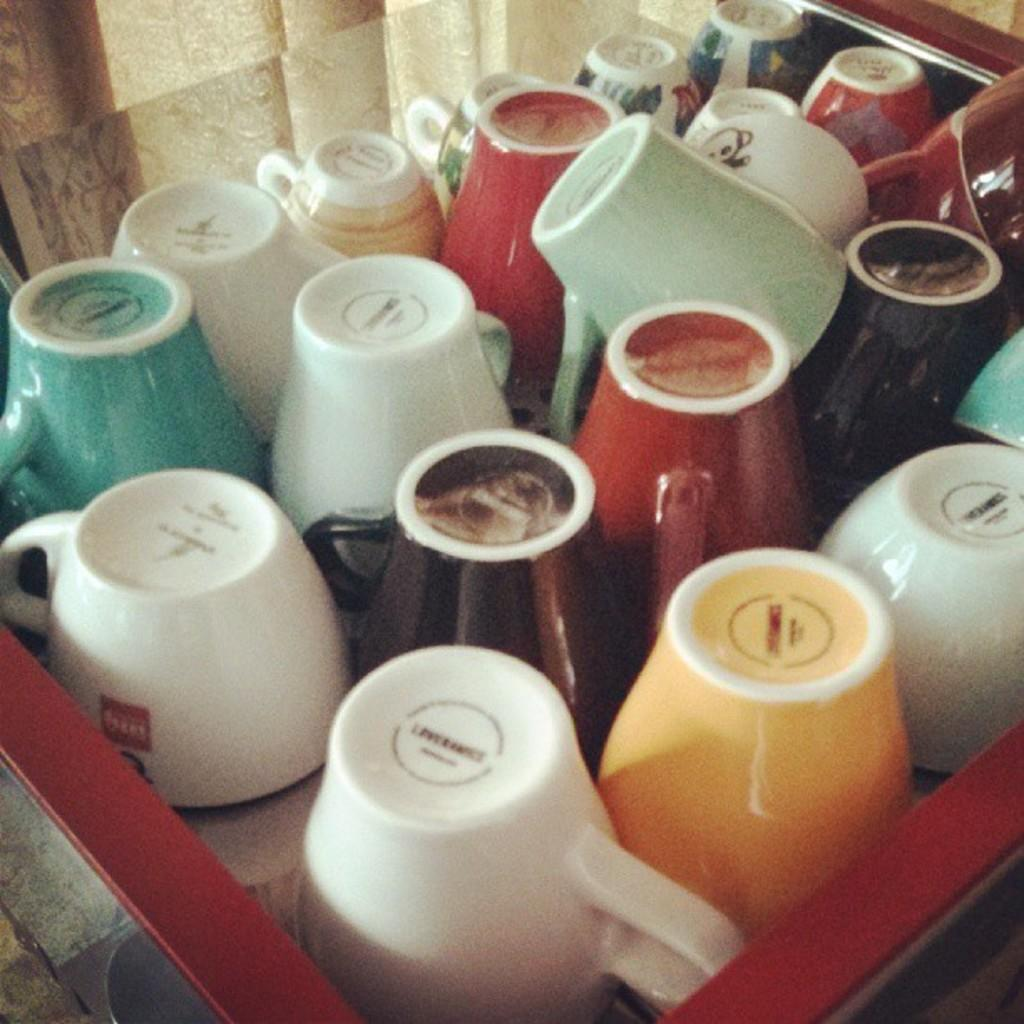What objects are on a platform in the image? There are colorful cups on a platform in the image. What type of container is visible in the image? There is a glass in the image. What type of window treatment is present in the image? There is a curtain in the image. What type of hope can be seen growing in the image? There is no plant or reference to hope in the image; it features colorful cups, a glass, and a curtain. 